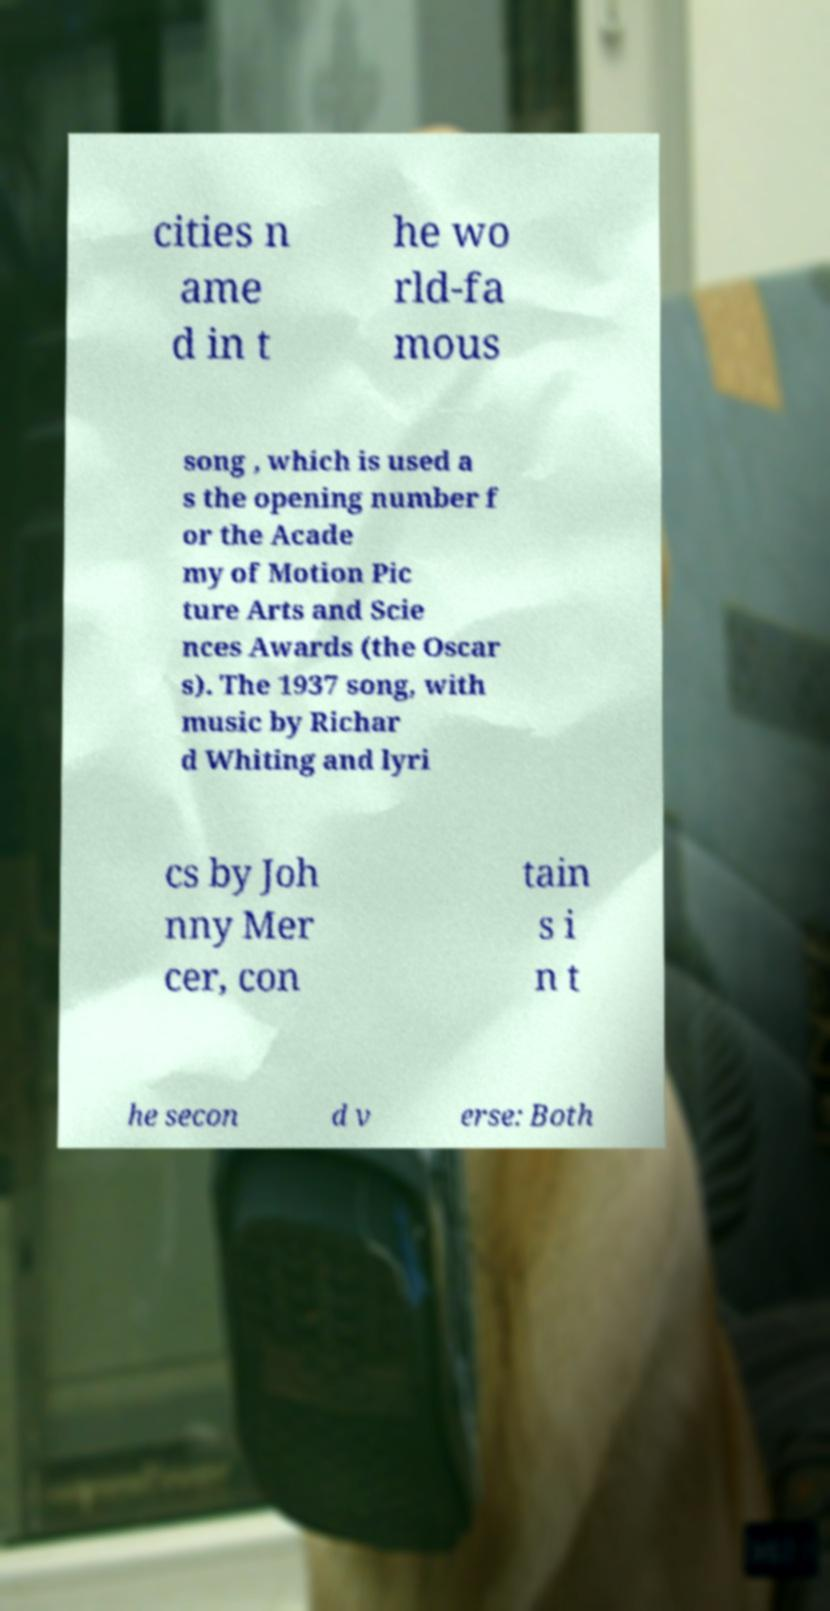Can you read and provide the text displayed in the image?This photo seems to have some interesting text. Can you extract and type it out for me? cities n ame d in t he wo rld-fa mous song , which is used a s the opening number f or the Acade my of Motion Pic ture Arts and Scie nces Awards (the Oscar s). The 1937 song, with music by Richar d Whiting and lyri cs by Joh nny Mer cer, con tain s i n t he secon d v erse: Both 